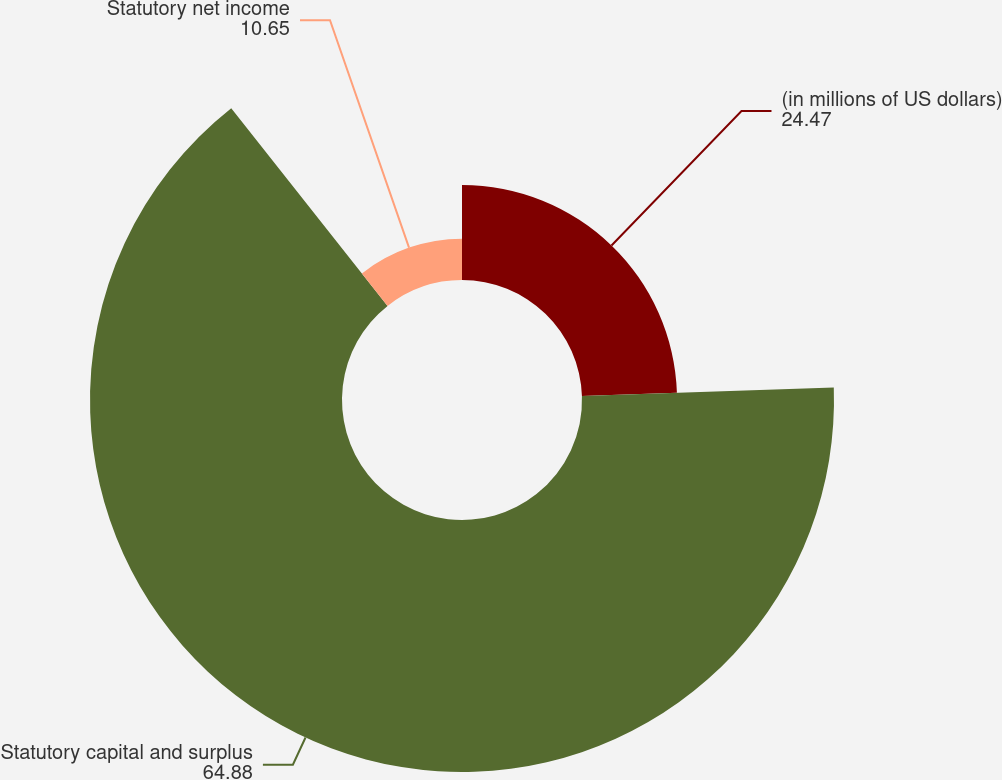Convert chart to OTSL. <chart><loc_0><loc_0><loc_500><loc_500><pie_chart><fcel>(in millions of US dollars)<fcel>Statutory capital and surplus<fcel>Statutory net income<nl><fcel>24.47%<fcel>64.88%<fcel>10.65%<nl></chart> 